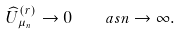Convert formula to latex. <formula><loc_0><loc_0><loc_500><loc_500>\widehat { U } _ { \mu _ { n } } ^ { ( r ) } \to 0 \quad a s n \to \infty .</formula> 